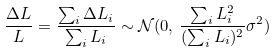Convert formula to latex. <formula><loc_0><loc_0><loc_500><loc_500>\frac { \Delta L } { L } = \frac { \sum _ { i } \Delta L _ { i } } { \sum _ { i } L _ { i } } \sim \mathcal { N } ( 0 , \, \frac { \sum _ { i } L _ { i } ^ { 2 } } { ( \sum _ { i } L _ { i } ) ^ { 2 } } \sigma ^ { 2 } )</formula> 